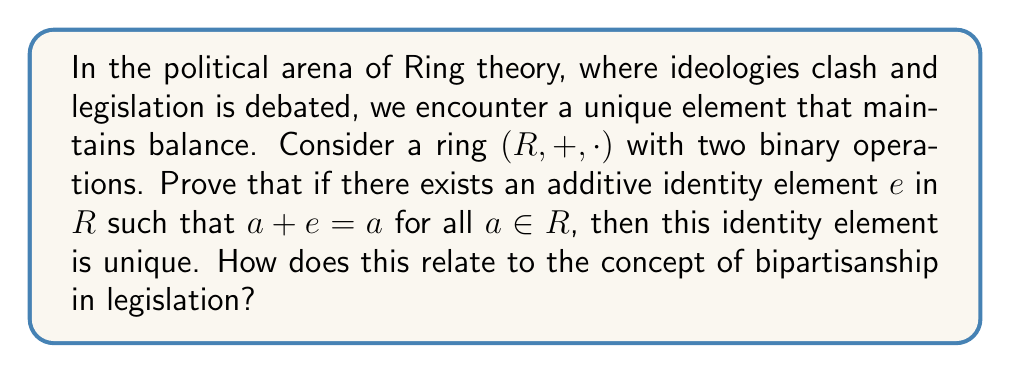Provide a solution to this math problem. Let's approach this proof step-by-step:

1) Assume that there exist two additive identity elements in $R$, let's call them $e$ and $e'$.

2) By definition of an additive identity element:
   $a + e = a$ for all $a \in R$
   $a + e' = a$ for all $a \in R$

3) Now, let's consider $e + e'$:
   $e + e' = e$ (since $e'$ is an identity element)
   $e + e' = e'$ (since $e$ is an identity element)

4) From steps 3, we can conclude:
   $e = e + e' = e'$

5) Therefore, $e = e'$, proving that the additive identity element is unique.

This uniqueness in Ring theory relates to bipartisanship in legislation as follows:
- The unique identity element represents a neutral ground or common baseline that both parties can agree upon.
- Just as adding the identity element to any ring element doesn't change it, bipartisan efforts should aim to maintain the core essence of legislation while finding common ground.
- The uniqueness ensures that there's only one such "neutral" position, emphasizing the importance of finding a single, agreed-upon starting point in bipartisan negotiations.
Answer: The additive identity element in a ring is unique. 